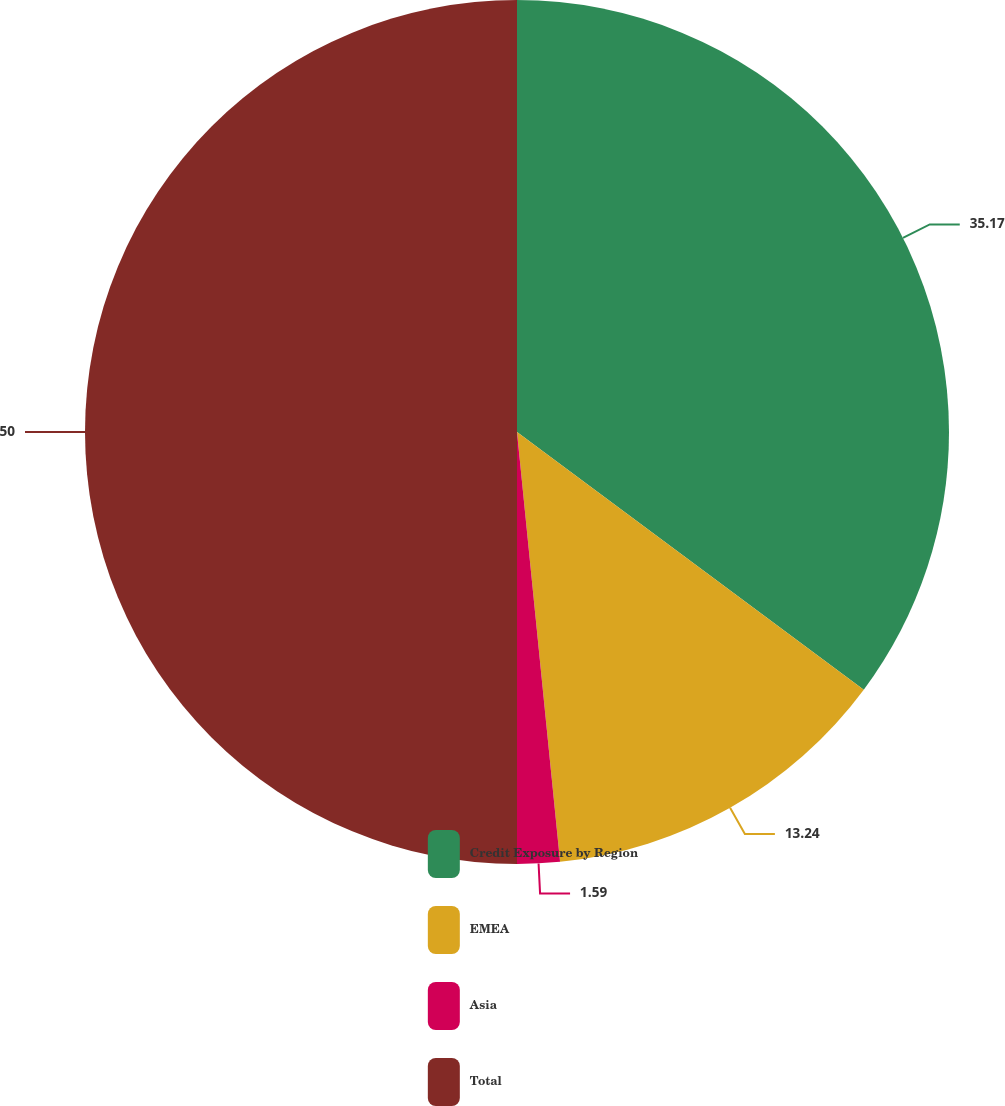<chart> <loc_0><loc_0><loc_500><loc_500><pie_chart><fcel>Credit Exposure by Region<fcel>EMEA<fcel>Asia<fcel>Total<nl><fcel>35.17%<fcel>13.24%<fcel>1.59%<fcel>50.0%<nl></chart> 